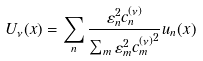<formula> <loc_0><loc_0><loc_500><loc_500>U _ { \nu } ( x ) = \sum _ { n } \frac { \varepsilon _ { n } ^ { 2 } c ^ { ( \nu ) } _ { n } } { \sum _ { m } \varepsilon _ { m } ^ { 2 } { c ^ { ( \nu ) } _ { m } } ^ { 2 } } u _ { n } ( x )</formula> 